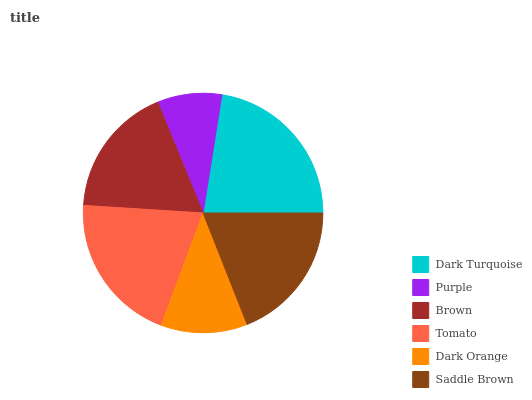Is Purple the minimum?
Answer yes or no. Yes. Is Dark Turquoise the maximum?
Answer yes or no. Yes. Is Brown the minimum?
Answer yes or no. No. Is Brown the maximum?
Answer yes or no. No. Is Brown greater than Purple?
Answer yes or no. Yes. Is Purple less than Brown?
Answer yes or no. Yes. Is Purple greater than Brown?
Answer yes or no. No. Is Brown less than Purple?
Answer yes or no. No. Is Saddle Brown the high median?
Answer yes or no. Yes. Is Brown the low median?
Answer yes or no. Yes. Is Dark Orange the high median?
Answer yes or no. No. Is Dark Turquoise the low median?
Answer yes or no. No. 